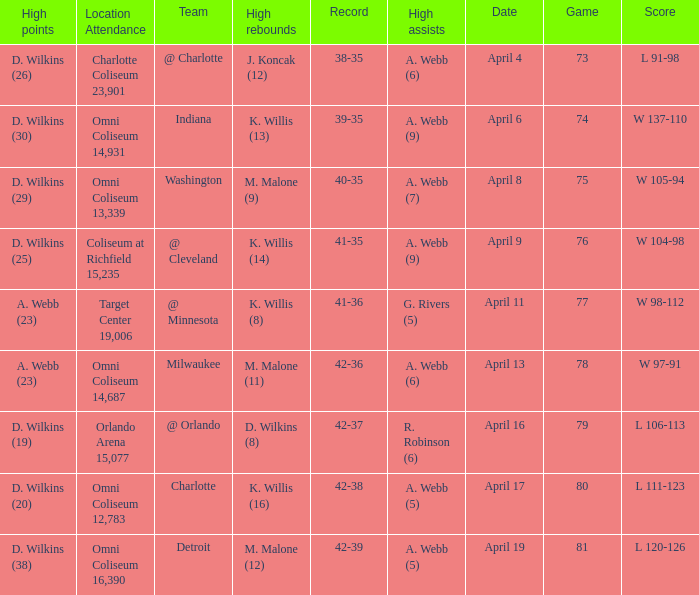What was the location and attendance when d. wilkins (29) had the high points? Omni Coliseum 13,339. 